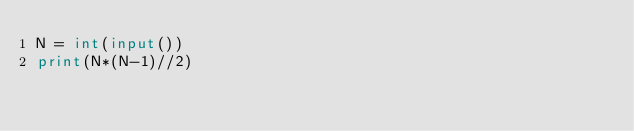Convert code to text. <code><loc_0><loc_0><loc_500><loc_500><_Python_>N = int(input())
print(N*(N-1)//2)</code> 